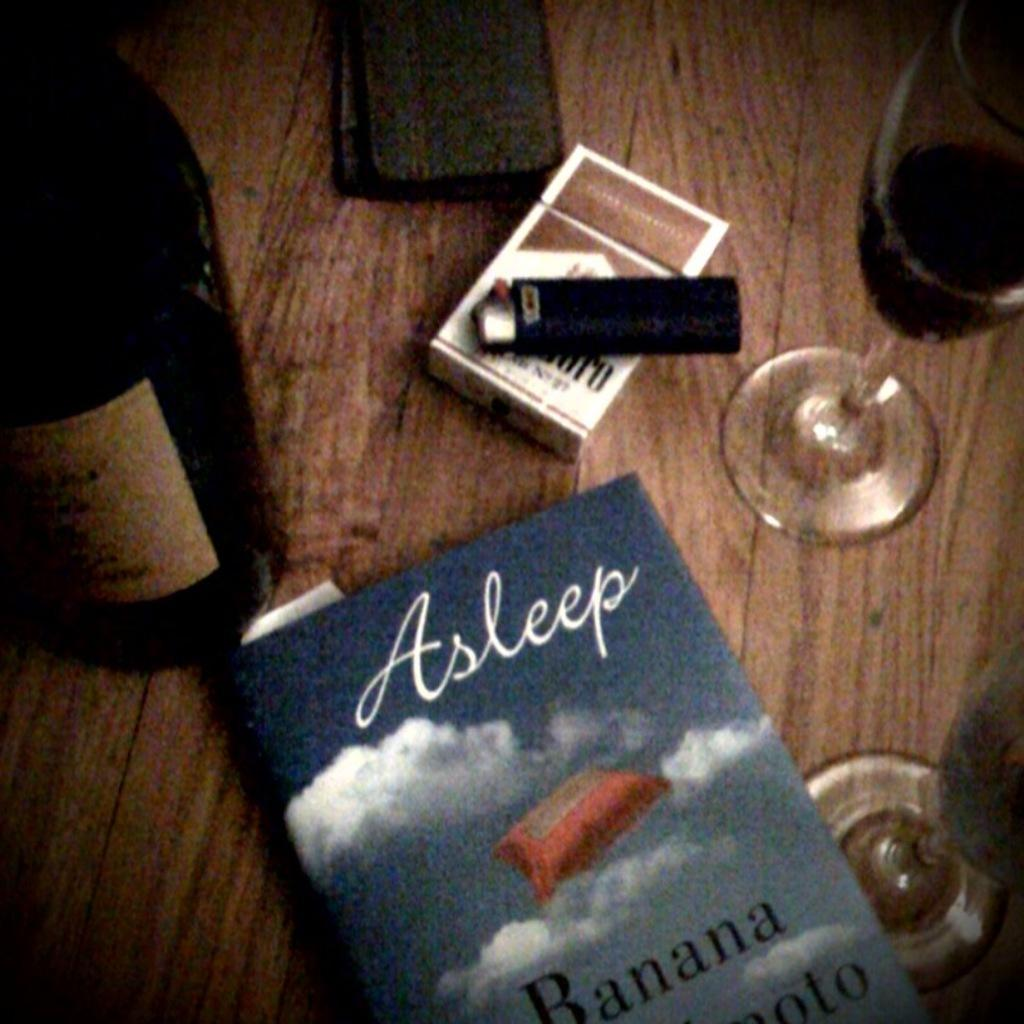<image>
Describe the image concisely. A book called asleep by a bottle and a pack of smokes on a table. 